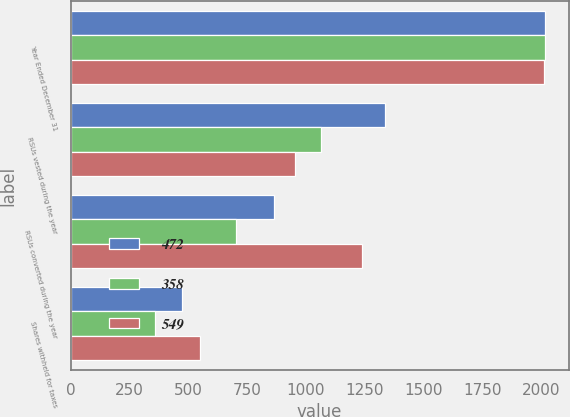Convert chart to OTSL. <chart><loc_0><loc_0><loc_500><loc_500><stacked_bar_chart><ecel><fcel>Year Ended December 31<fcel>RSUs vested during the year<fcel>RSUs converted during the year<fcel>Shares withheld for taxes<nl><fcel>472<fcel>2017<fcel>1337<fcel>865<fcel>472<nl><fcel>358<fcel>2016<fcel>1063<fcel>705<fcel>358<nl><fcel>549<fcel>2015<fcel>954<fcel>1238<fcel>549<nl></chart> 